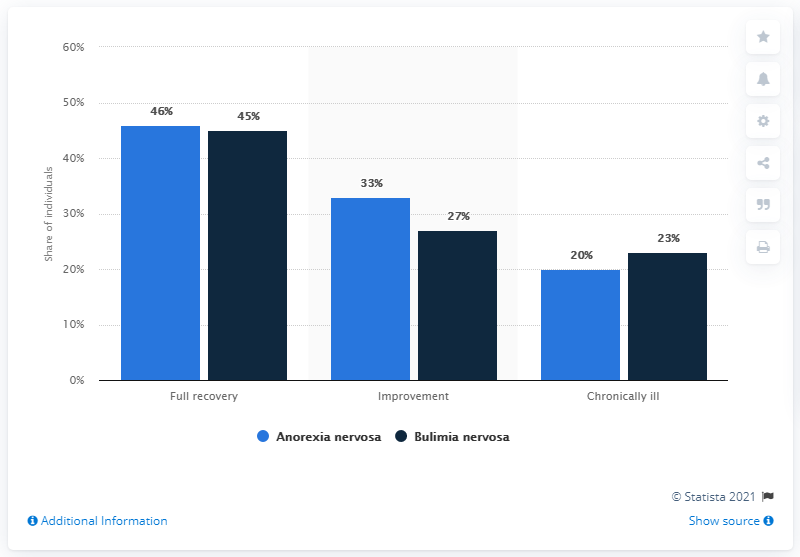Point out several critical features in this image. The sum total percentage of improvement for individuals suffering from Anorexia Nervosa and Bulimia Nervosa disorders is 60%. Approximately 46% of individuals with anorexia nervosa disorder are fully recovered, according to recent studies. 